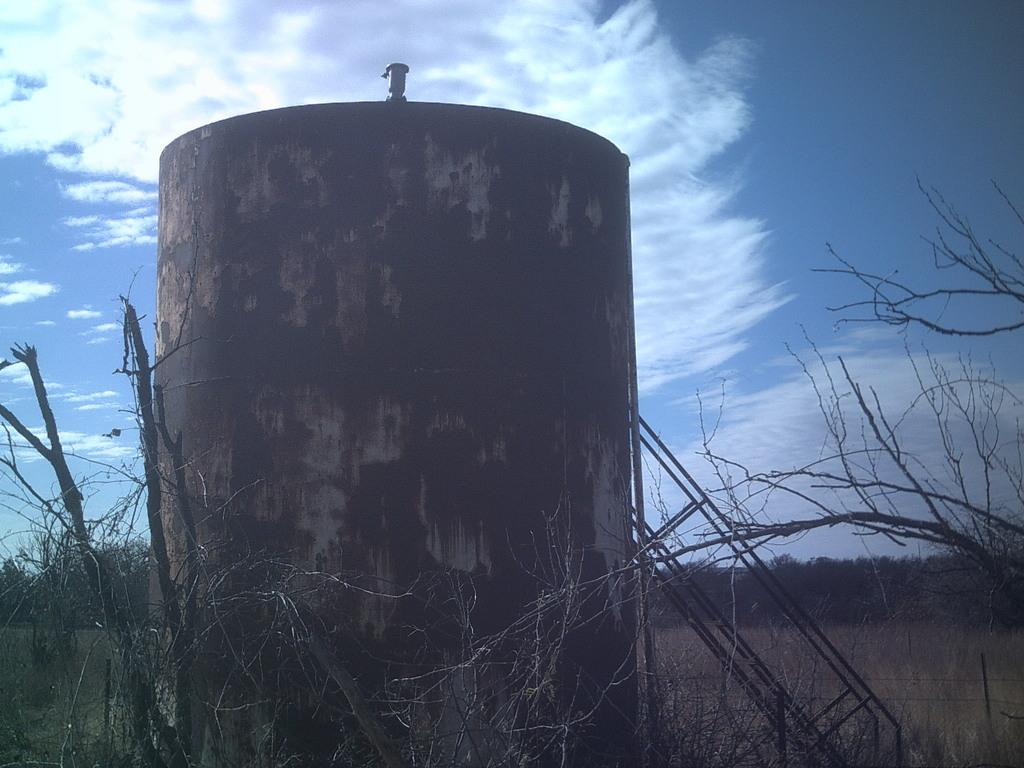What is the main structure in the image? There is a large container with stairs in the image. What type of vegetation can be seen in the image? There are dried stems and grass visible in the image. What type of barrier is present in the image? There is a fence in the image. What can be seen in the background of the image? Trees and the sky are visible in the background of the image. How would you describe the sky in the image? The sky appears to be cloudy in the image. Can you see a boat sailing in the sky in the image? No, there is no boat visible in the image, and the sky is not depicted as a body of water. 